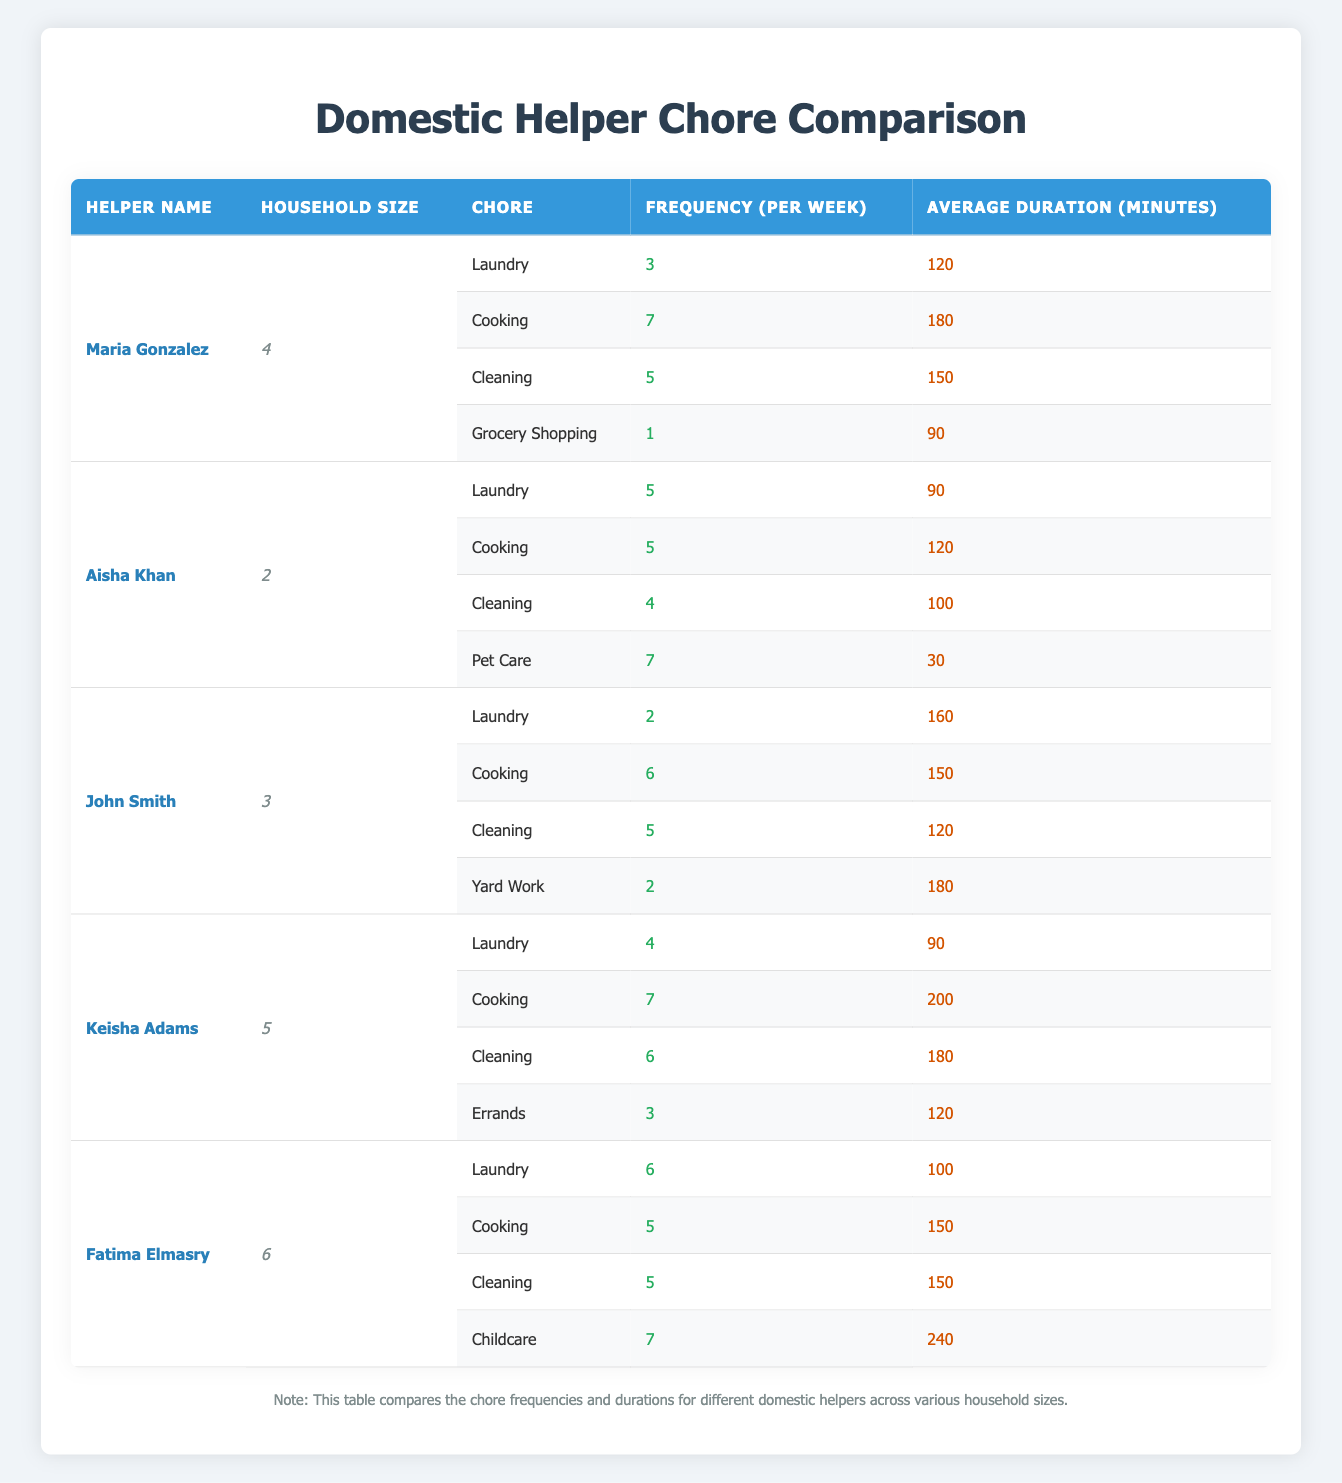What is the frequency of Cooking for Maria Gonzalez? Maria Gonzalez cooks 7 times per week according to the table.
Answer: 7 How many minutes does Keisha Adams spend on Cleaning on average? Keisha Adams spends an average of 180 minutes on Cleaning, as stated in the table.
Answer: 180 What is the total average duration for Laundry and Cooking combined for John Smith? John Smith spends 160 minutes on Laundry and 150 minutes on Cooking. The total duration is 160 + 150 = 310 minutes.
Answer: 310 Does Aisha Khan perform Pet Care more frequently than Cleaning? Aisha Khan performs Pet Care 7 times a week and Cleaning 4 times a week. Since 7 > 4, the statement is true.
Answer: Yes Which helper has the highest average duration for Childcare? Fatima Elmasry has the highest average duration for Childcare at 240 minutes, based on the table.
Answer: 240 What is the average frequency of Grocery Shopping for all helpers combined? Only Maria Gonzalez does Grocery Shopping, once a week. Every other helper doesn't do this chore, making the average frequency for Grocery Shopping = 1/5 = 0.2.
Answer: 0.2 Is the average duration for Cooking higher than 170 minutes for the helpers listed? Maria Gonzalez (180), Keisha Adams (200), John Smith (150), Aisha Khan (120), and Fatima Elmasry (150) have Cooking durations. The average is (180 + 200 + 150 + 120 + 150) / 5 = 160. The statement is false.
Answer: No What is the frequency of Laundry for Fatima Elmasry compared to Keisha Adams? Fatima Elmasry does Laundry 6 times a week, while Keisha Adams does it 4 times. Since 6 > 4, Fatima does Laundry more frequently.
Answer: Yes If you sum the frequency of all chores for Aisha Khan, what is the total? Aisha Khan does Laundry (5), Cooking (5), Cleaning (4), and Pet Care (7). The sum is 5 + 5 + 4 + 7 = 21.
Answer: 21 Which chore has the lowest frequency for Fatima Elmasry? Fatima Elmasry has the lowest frequency with Laundry, which is 6, but also performs Cooking 5 times, Cleaning 5 times, and Childcare 7 times. However, the lowest frequency is Cooking with 5 times.
Answer: Cooking What is the median average duration of chores for all helpers combined? For calculating the median, we can take all average durations: 120, 180, 150, 90, 90, 120, 100, 150, 150, 200, 180, 240. Arranging gives us: 90, 90, 100, 120, 120, 150, 150, 150, 180, 180, 200, 240. The median (average of 6th and 7th) is (150 + 150)/2 = 150.
Answer: 150 